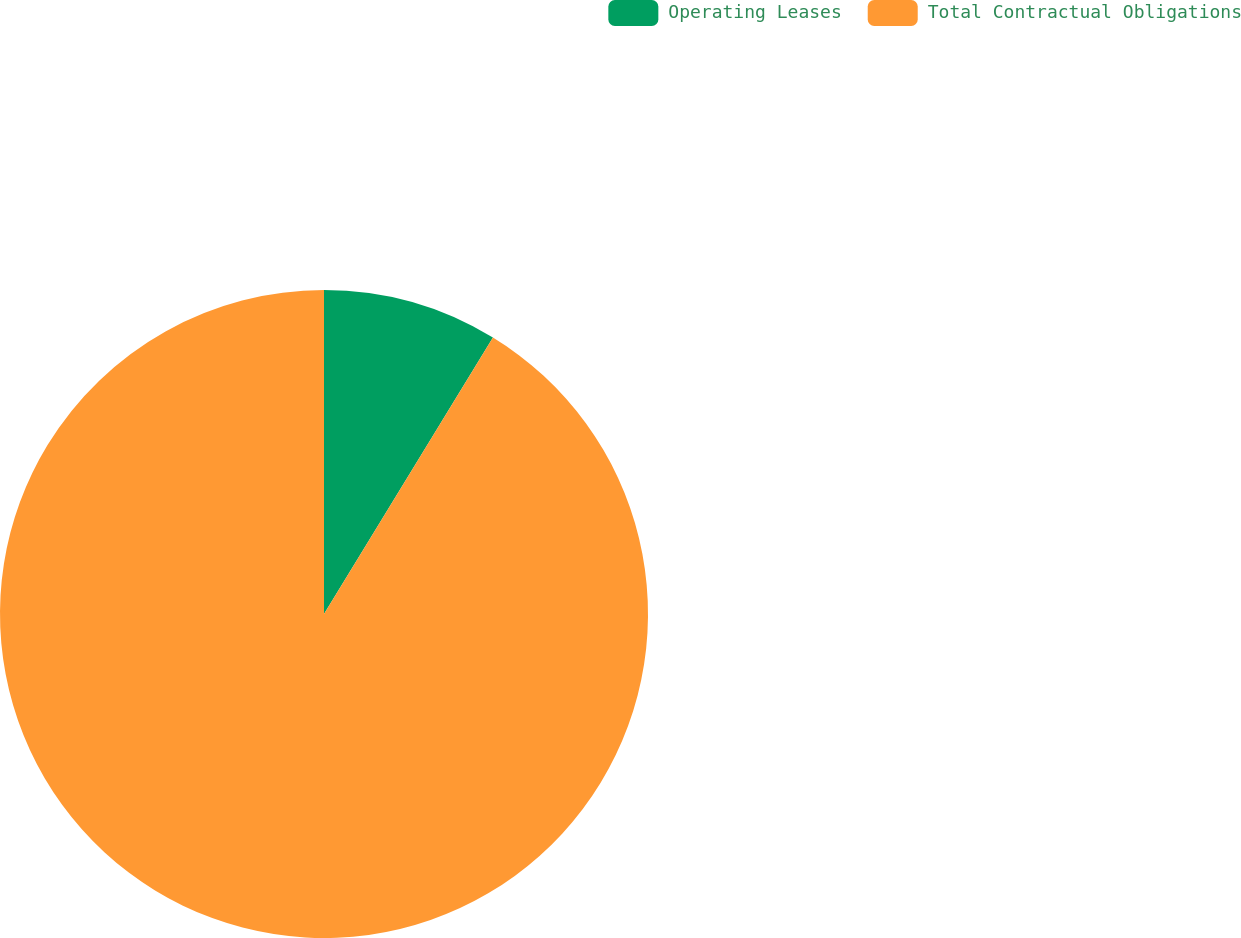<chart> <loc_0><loc_0><loc_500><loc_500><pie_chart><fcel>Operating Leases<fcel>Total Contractual Obligations<nl><fcel>8.73%<fcel>91.27%<nl></chart> 